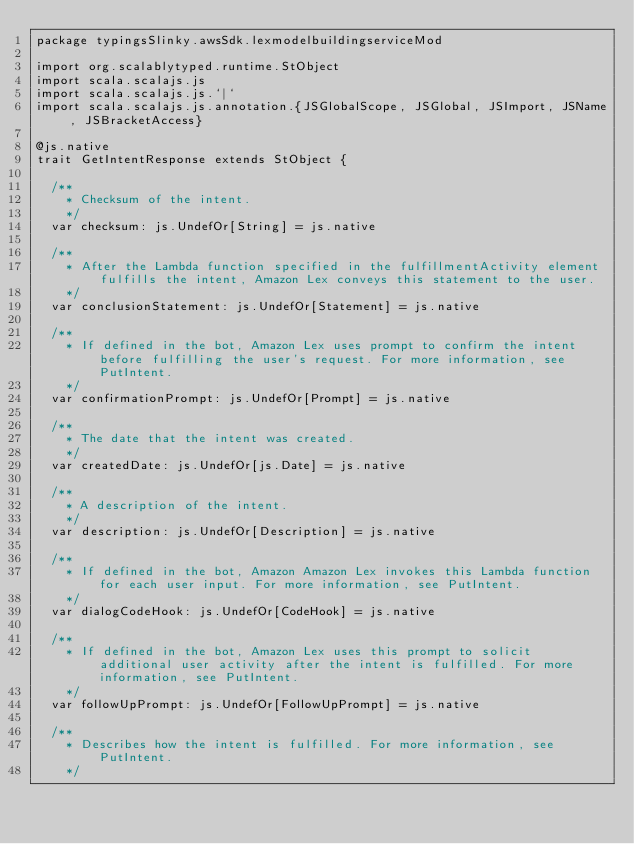<code> <loc_0><loc_0><loc_500><loc_500><_Scala_>package typingsSlinky.awsSdk.lexmodelbuildingserviceMod

import org.scalablytyped.runtime.StObject
import scala.scalajs.js
import scala.scalajs.js.`|`
import scala.scalajs.js.annotation.{JSGlobalScope, JSGlobal, JSImport, JSName, JSBracketAccess}

@js.native
trait GetIntentResponse extends StObject {
  
  /**
    * Checksum of the intent.
    */
  var checksum: js.UndefOr[String] = js.native
  
  /**
    * After the Lambda function specified in the fulfillmentActivity element fulfills the intent, Amazon Lex conveys this statement to the user.
    */
  var conclusionStatement: js.UndefOr[Statement] = js.native
  
  /**
    * If defined in the bot, Amazon Lex uses prompt to confirm the intent before fulfilling the user's request. For more information, see PutIntent. 
    */
  var confirmationPrompt: js.UndefOr[Prompt] = js.native
  
  /**
    * The date that the intent was created.
    */
  var createdDate: js.UndefOr[js.Date] = js.native
  
  /**
    * A description of the intent.
    */
  var description: js.UndefOr[Description] = js.native
  
  /**
    * If defined in the bot, Amazon Amazon Lex invokes this Lambda function for each user input. For more information, see PutIntent. 
    */
  var dialogCodeHook: js.UndefOr[CodeHook] = js.native
  
  /**
    * If defined in the bot, Amazon Lex uses this prompt to solicit additional user activity after the intent is fulfilled. For more information, see PutIntent.
    */
  var followUpPrompt: js.UndefOr[FollowUpPrompt] = js.native
  
  /**
    * Describes how the intent is fulfilled. For more information, see PutIntent. 
    */</code> 